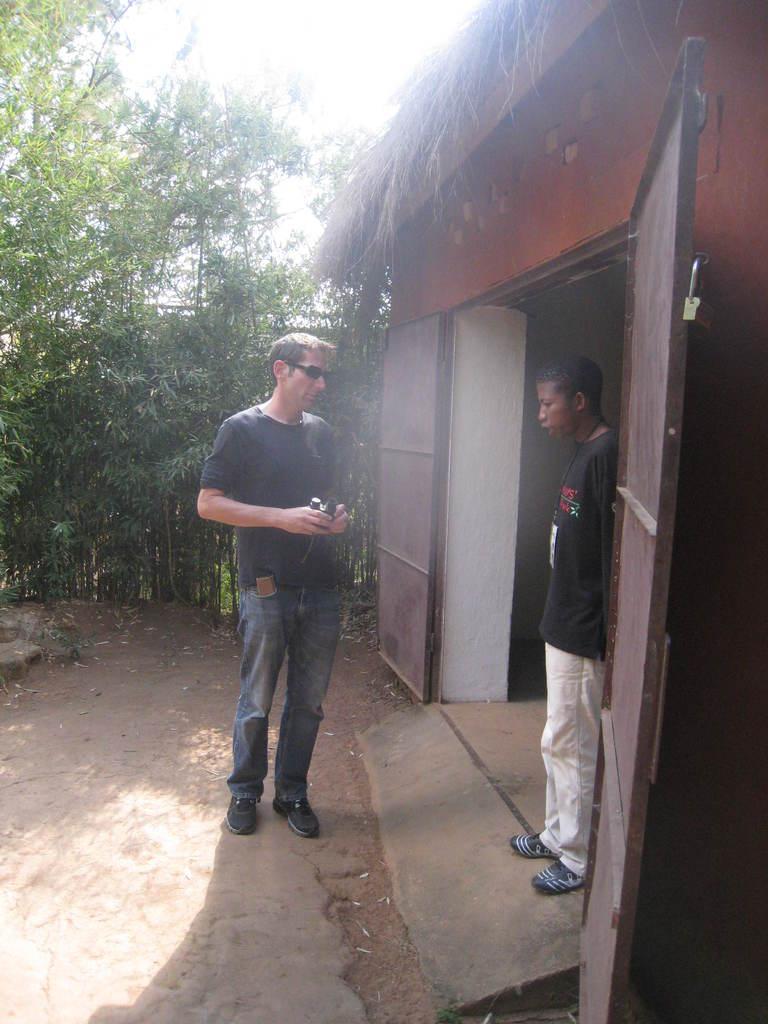Please provide a concise description of this image. This image consists of trees on the left side. There are two persons in the middle. There is door on the right side. There is sky at the top. 